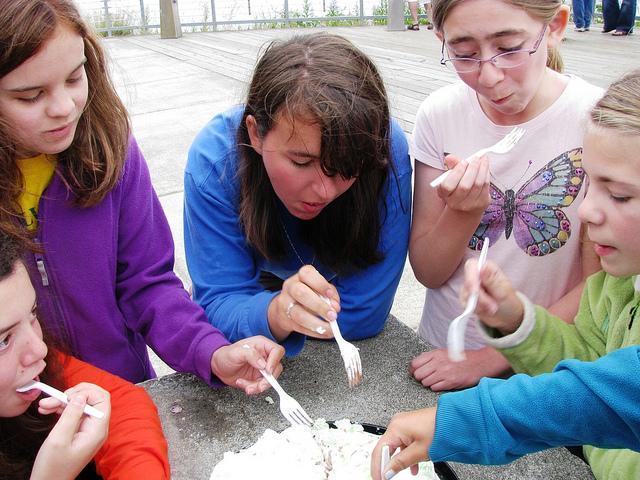How many people can be seen?
Give a very brief answer. 6. 